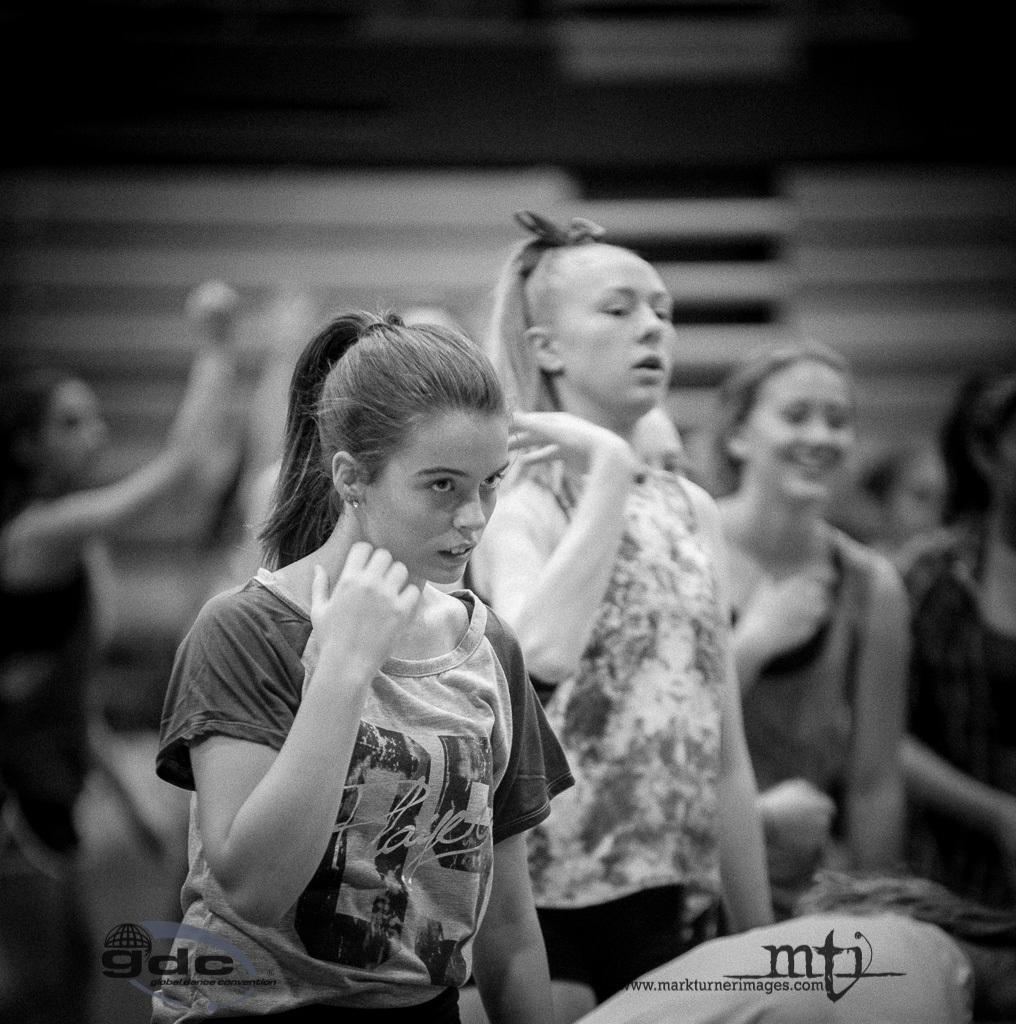Who is present in the image? There are women in the image. What are the women doing in the image? The women are standing and doing an exercise. What can be seen in the background of the image? There is a wall in the background of the image. Are there any architectural features visible on the wall? Yes, there are steps on the wall in the background. Where is the sink and faucet located in the image? There is no sink or faucet present in the image. Are there any police officers visible in the image? There are no police officers visible in the image. 